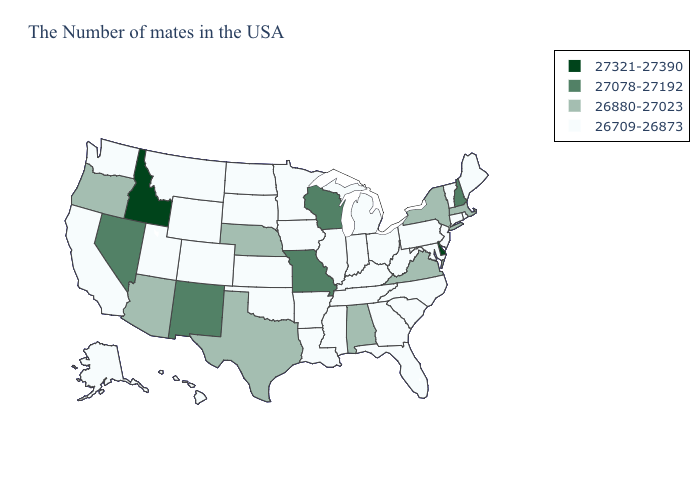Which states have the lowest value in the USA?
Write a very short answer. Maine, Rhode Island, Vermont, Connecticut, New Jersey, Maryland, Pennsylvania, North Carolina, South Carolina, West Virginia, Ohio, Florida, Georgia, Michigan, Kentucky, Indiana, Tennessee, Illinois, Mississippi, Louisiana, Arkansas, Minnesota, Iowa, Kansas, Oklahoma, South Dakota, North Dakota, Wyoming, Colorado, Utah, Montana, California, Washington, Alaska, Hawaii. Name the states that have a value in the range 26880-27023?
Concise answer only. Massachusetts, New York, Virginia, Alabama, Nebraska, Texas, Arizona, Oregon. Does Idaho have the highest value in the USA?
Quick response, please. Yes. What is the highest value in the USA?
Write a very short answer. 27321-27390. What is the lowest value in the Northeast?
Concise answer only. 26709-26873. Among the states that border North Carolina , does South Carolina have the highest value?
Give a very brief answer. No. What is the value of Indiana?
Concise answer only. 26709-26873. What is the value of South Carolina?
Quick response, please. 26709-26873. What is the value of Maine?
Keep it brief. 26709-26873. Name the states that have a value in the range 26880-27023?
Keep it brief. Massachusetts, New York, Virginia, Alabama, Nebraska, Texas, Arizona, Oregon. What is the value of Oklahoma?
Quick response, please. 26709-26873. Does the map have missing data?
Keep it brief. No. What is the highest value in the South ?
Give a very brief answer. 27321-27390. Does Nebraska have the lowest value in the MidWest?
Write a very short answer. No. 